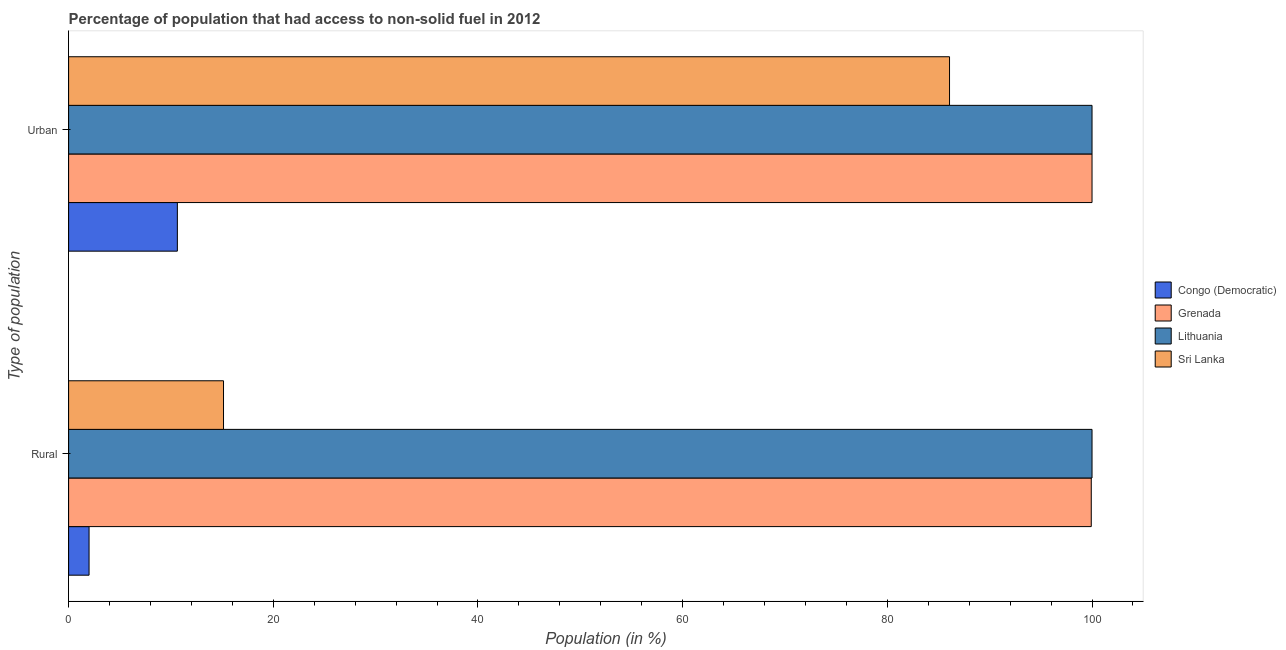How many groups of bars are there?
Your response must be concise. 2. How many bars are there on the 2nd tick from the top?
Provide a short and direct response. 4. What is the label of the 2nd group of bars from the top?
Give a very brief answer. Rural. What is the urban population in Sri Lanka?
Give a very brief answer. 86.08. Across all countries, what is the minimum urban population?
Offer a terse response. 10.63. In which country was the urban population maximum?
Provide a succinct answer. Grenada. In which country was the urban population minimum?
Offer a terse response. Congo (Democratic). What is the total urban population in the graph?
Ensure brevity in your answer.  296.7. What is the difference between the rural population in Congo (Democratic) and the urban population in Grenada?
Give a very brief answer. -98. What is the average urban population per country?
Your answer should be compact. 74.18. What is the difference between the rural population and urban population in Grenada?
Offer a very short reply. -0.07. In how many countries, is the rural population greater than 24 %?
Give a very brief answer. 2. What is the ratio of the rural population in Lithuania to that in Sri Lanka?
Offer a very short reply. 6.61. Is the urban population in Sri Lanka less than that in Grenada?
Provide a succinct answer. Yes. In how many countries, is the urban population greater than the average urban population taken over all countries?
Offer a terse response. 3. What does the 1st bar from the top in Rural represents?
Your response must be concise. Sri Lanka. What does the 3rd bar from the bottom in Urban represents?
Give a very brief answer. Lithuania. Are all the bars in the graph horizontal?
Provide a succinct answer. Yes. How many countries are there in the graph?
Your response must be concise. 4. What is the difference between two consecutive major ticks on the X-axis?
Provide a succinct answer. 20. Are the values on the major ticks of X-axis written in scientific E-notation?
Your response must be concise. No. Does the graph contain grids?
Give a very brief answer. No. Where does the legend appear in the graph?
Ensure brevity in your answer.  Center right. How many legend labels are there?
Make the answer very short. 4. What is the title of the graph?
Your answer should be very brief. Percentage of population that had access to non-solid fuel in 2012. Does "Netherlands" appear as one of the legend labels in the graph?
Your response must be concise. No. What is the label or title of the Y-axis?
Make the answer very short. Type of population. What is the Population (in %) in Congo (Democratic) in Rural?
Offer a very short reply. 2. What is the Population (in %) of Grenada in Rural?
Give a very brief answer. 99.93. What is the Population (in %) in Lithuania in Rural?
Your answer should be compact. 100. What is the Population (in %) of Sri Lanka in Rural?
Ensure brevity in your answer.  15.14. What is the Population (in %) in Congo (Democratic) in Urban?
Provide a succinct answer. 10.63. What is the Population (in %) of Sri Lanka in Urban?
Provide a short and direct response. 86.08. Across all Type of population, what is the maximum Population (in %) in Congo (Democratic)?
Provide a succinct answer. 10.63. Across all Type of population, what is the maximum Population (in %) of Grenada?
Give a very brief answer. 100. Across all Type of population, what is the maximum Population (in %) of Sri Lanka?
Give a very brief answer. 86.08. Across all Type of population, what is the minimum Population (in %) in Congo (Democratic)?
Provide a succinct answer. 2. Across all Type of population, what is the minimum Population (in %) in Grenada?
Offer a terse response. 99.93. Across all Type of population, what is the minimum Population (in %) of Sri Lanka?
Your answer should be compact. 15.14. What is the total Population (in %) in Congo (Democratic) in the graph?
Keep it short and to the point. 12.63. What is the total Population (in %) of Grenada in the graph?
Keep it short and to the point. 199.93. What is the total Population (in %) of Sri Lanka in the graph?
Ensure brevity in your answer.  101.21. What is the difference between the Population (in %) in Congo (Democratic) in Rural and that in Urban?
Ensure brevity in your answer.  -8.63. What is the difference between the Population (in %) in Grenada in Rural and that in Urban?
Your response must be concise. -0.07. What is the difference between the Population (in %) in Sri Lanka in Rural and that in Urban?
Offer a terse response. -70.94. What is the difference between the Population (in %) of Congo (Democratic) in Rural and the Population (in %) of Grenada in Urban?
Provide a succinct answer. -98. What is the difference between the Population (in %) in Congo (Democratic) in Rural and the Population (in %) in Lithuania in Urban?
Your response must be concise. -98. What is the difference between the Population (in %) in Congo (Democratic) in Rural and the Population (in %) in Sri Lanka in Urban?
Provide a succinct answer. -84.08. What is the difference between the Population (in %) in Grenada in Rural and the Population (in %) in Lithuania in Urban?
Give a very brief answer. -0.07. What is the difference between the Population (in %) in Grenada in Rural and the Population (in %) in Sri Lanka in Urban?
Give a very brief answer. 13.85. What is the difference between the Population (in %) in Lithuania in Rural and the Population (in %) in Sri Lanka in Urban?
Your answer should be compact. 13.92. What is the average Population (in %) of Congo (Democratic) per Type of population?
Your answer should be very brief. 6.31. What is the average Population (in %) in Grenada per Type of population?
Give a very brief answer. 99.96. What is the average Population (in %) of Sri Lanka per Type of population?
Offer a very short reply. 50.61. What is the difference between the Population (in %) in Congo (Democratic) and Population (in %) in Grenada in Rural?
Your answer should be very brief. -97.93. What is the difference between the Population (in %) in Congo (Democratic) and Population (in %) in Lithuania in Rural?
Provide a succinct answer. -98. What is the difference between the Population (in %) of Congo (Democratic) and Population (in %) of Sri Lanka in Rural?
Give a very brief answer. -13.14. What is the difference between the Population (in %) in Grenada and Population (in %) in Lithuania in Rural?
Your answer should be compact. -0.07. What is the difference between the Population (in %) of Grenada and Population (in %) of Sri Lanka in Rural?
Provide a succinct answer. 84.79. What is the difference between the Population (in %) of Lithuania and Population (in %) of Sri Lanka in Rural?
Offer a terse response. 84.86. What is the difference between the Population (in %) of Congo (Democratic) and Population (in %) of Grenada in Urban?
Provide a succinct answer. -89.37. What is the difference between the Population (in %) of Congo (Democratic) and Population (in %) of Lithuania in Urban?
Ensure brevity in your answer.  -89.37. What is the difference between the Population (in %) of Congo (Democratic) and Population (in %) of Sri Lanka in Urban?
Make the answer very short. -75.45. What is the difference between the Population (in %) of Grenada and Population (in %) of Sri Lanka in Urban?
Offer a very short reply. 13.92. What is the difference between the Population (in %) of Lithuania and Population (in %) of Sri Lanka in Urban?
Offer a very short reply. 13.92. What is the ratio of the Population (in %) in Congo (Democratic) in Rural to that in Urban?
Your response must be concise. 0.19. What is the ratio of the Population (in %) in Grenada in Rural to that in Urban?
Make the answer very short. 1. What is the ratio of the Population (in %) in Lithuania in Rural to that in Urban?
Your response must be concise. 1. What is the ratio of the Population (in %) of Sri Lanka in Rural to that in Urban?
Provide a short and direct response. 0.18. What is the difference between the highest and the second highest Population (in %) in Congo (Democratic)?
Offer a terse response. 8.63. What is the difference between the highest and the second highest Population (in %) of Grenada?
Give a very brief answer. 0.07. What is the difference between the highest and the second highest Population (in %) in Sri Lanka?
Ensure brevity in your answer.  70.94. What is the difference between the highest and the lowest Population (in %) of Congo (Democratic)?
Provide a succinct answer. 8.63. What is the difference between the highest and the lowest Population (in %) of Grenada?
Ensure brevity in your answer.  0.07. What is the difference between the highest and the lowest Population (in %) in Lithuania?
Your answer should be compact. 0. What is the difference between the highest and the lowest Population (in %) in Sri Lanka?
Give a very brief answer. 70.94. 